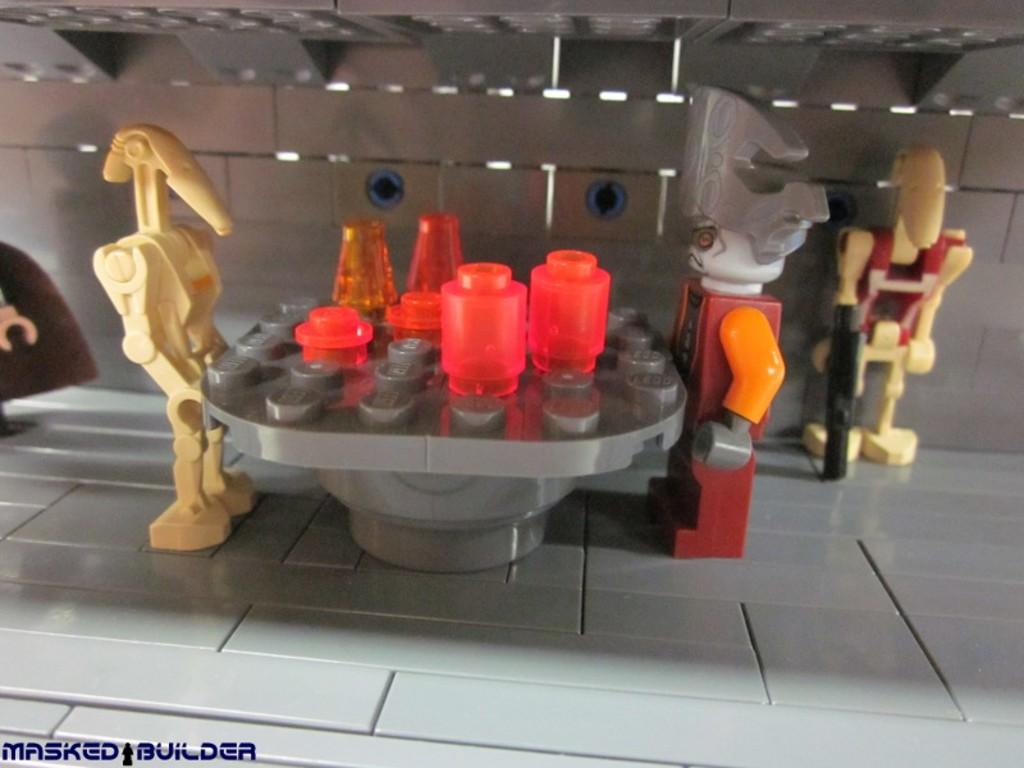What objects can be seen in the image? There are toys in the image. Is there any text present in the image? Yes, there is text in the bottom left of the image. What type of oatmeal is being served in the image? There is no oatmeal present in the image; it features toys and text. 